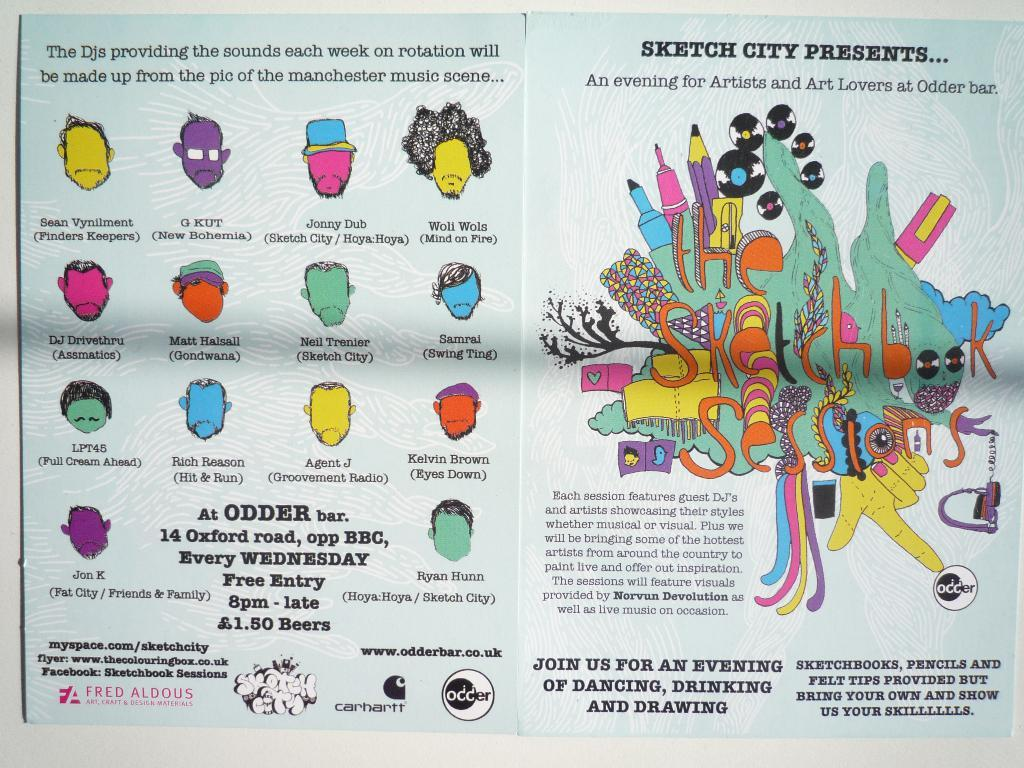<image>
Summarize the visual content of the image. An open book with Sketch City Presents written on the right. 